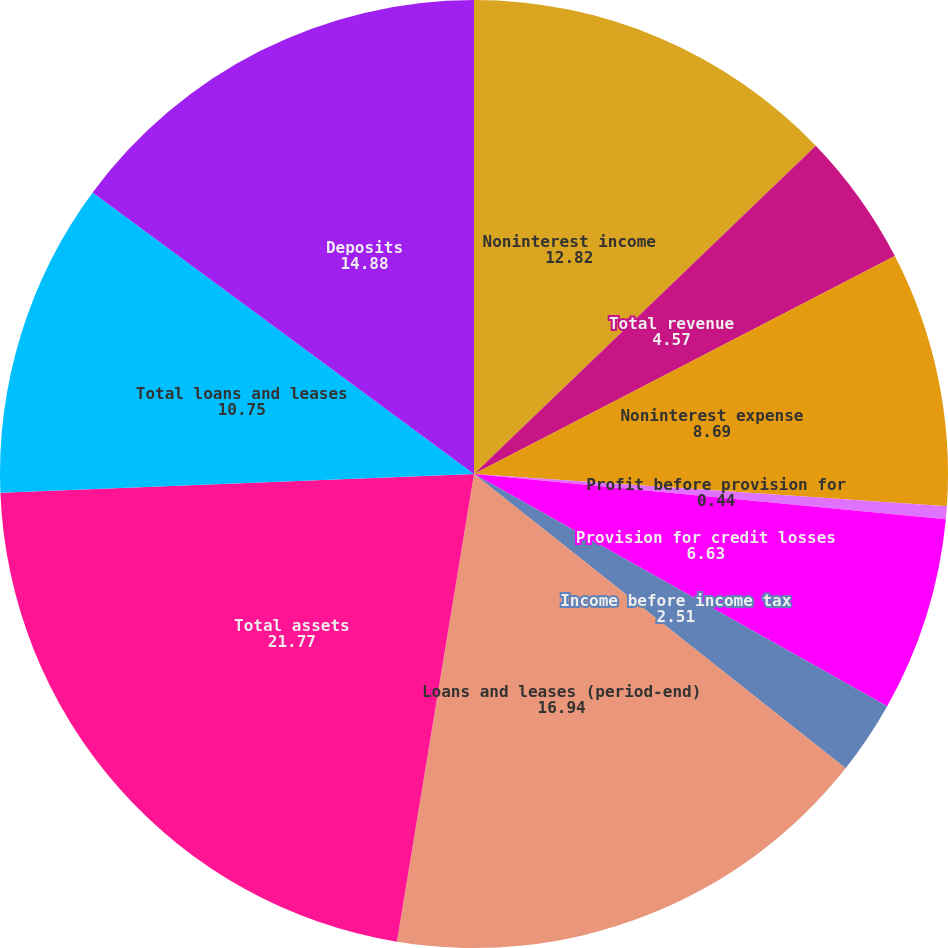Convert chart. <chart><loc_0><loc_0><loc_500><loc_500><pie_chart><fcel>Noninterest income<fcel>Total revenue<fcel>Noninterest expense<fcel>Profit before provision for<fcel>Provision for credit losses<fcel>Income before income tax<fcel>Loans and leases (period-end)<fcel>Total assets<fcel>Total loans and leases<fcel>Deposits<nl><fcel>12.82%<fcel>4.57%<fcel>8.69%<fcel>0.44%<fcel>6.63%<fcel>2.51%<fcel>16.94%<fcel>21.77%<fcel>10.75%<fcel>14.88%<nl></chart> 